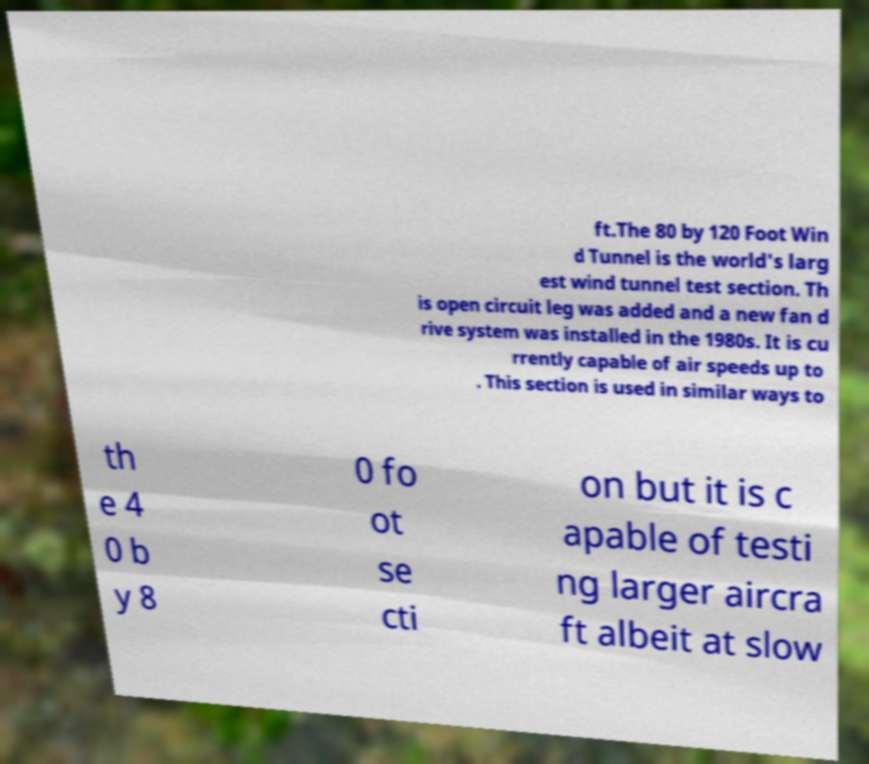Can you read and provide the text displayed in the image?This photo seems to have some interesting text. Can you extract and type it out for me? ft.The 80 by 120 Foot Win d Tunnel is the world's larg est wind tunnel test section. Th is open circuit leg was added and a new fan d rive system was installed in the 1980s. It is cu rrently capable of air speeds up to . This section is used in similar ways to th e 4 0 b y 8 0 fo ot se cti on but it is c apable of testi ng larger aircra ft albeit at slow 